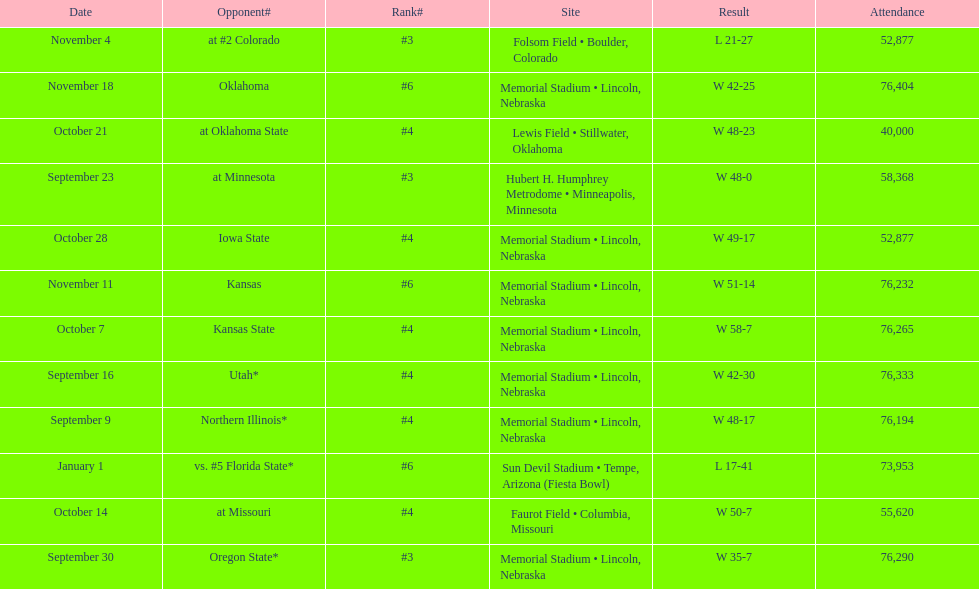What site at most is taken place? Memorial Stadium • Lincoln, Nebraska. 